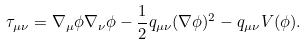Convert formula to latex. <formula><loc_0><loc_0><loc_500><loc_500>\tau _ { \mu \nu } = \nabla _ { \mu } \phi \nabla _ { \nu } \phi - \frac { 1 } { 2 } q _ { \mu \nu } ( \nabla \phi ) ^ { 2 } - q _ { \mu \nu } V ( \phi ) .</formula> 